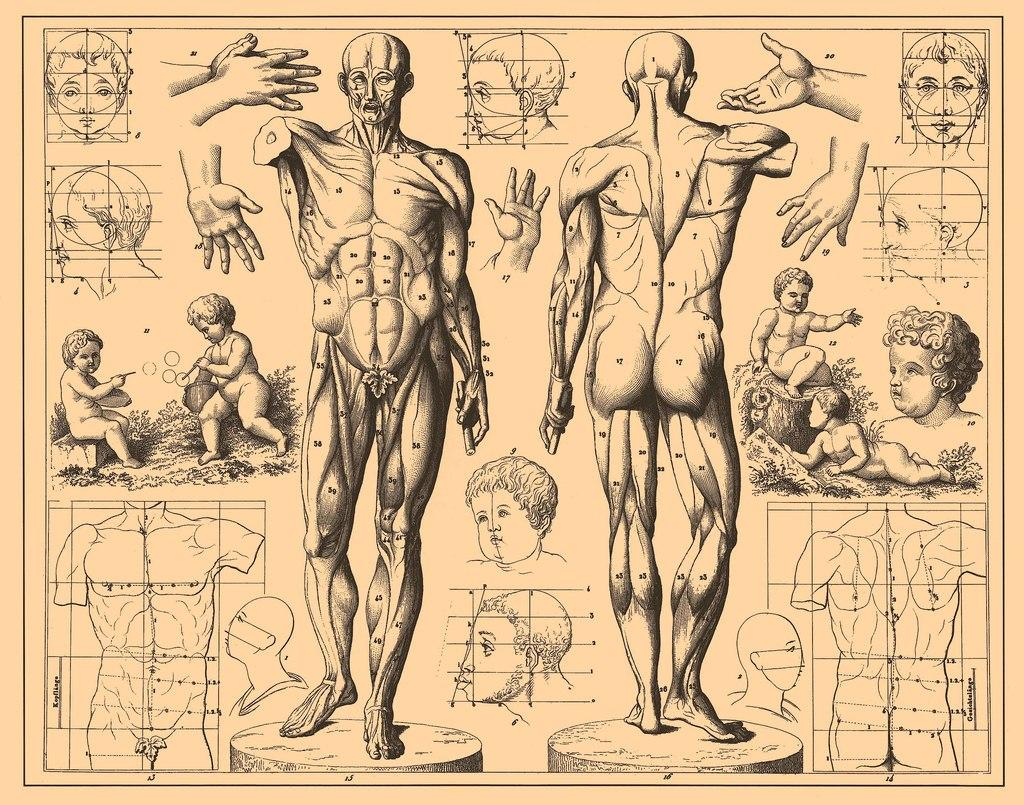What type of images can be seen on the paper in the image? There are pictures of a human body printed on paper in the image. What additional information is provided in the images? There are other pictures showing measurements of the body parts in the image. What type of joke is being told by the mouth in the image? There is no mouth or joke present in the image; it only contains pictures of a human body and measurements of body parts. 